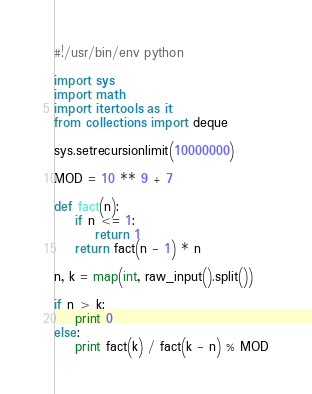<code> <loc_0><loc_0><loc_500><loc_500><_Python_>#!/usr/bin/env python

import sys
import math
import itertools as it
from collections import deque

sys.setrecursionlimit(10000000)

MOD = 10 ** 9 + 7

def fact(n):
    if n <= 1:
        return 1
    return fact(n - 1) * n

n, k = map(int, raw_input().split())

if n > k:
    print 0
else:
    print fact(k) / fact(k - n) % MOD
</code> 